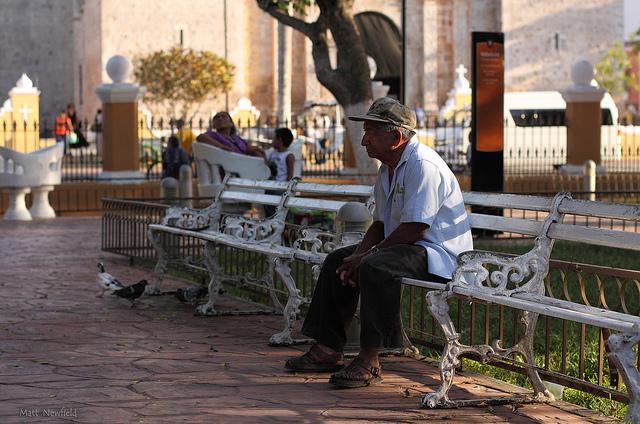Are the benches joined together?
Write a very short answer. Yes. Is this near a religious place?
Write a very short answer. Yes. Is the man alone?
Be succinct. Yes. 